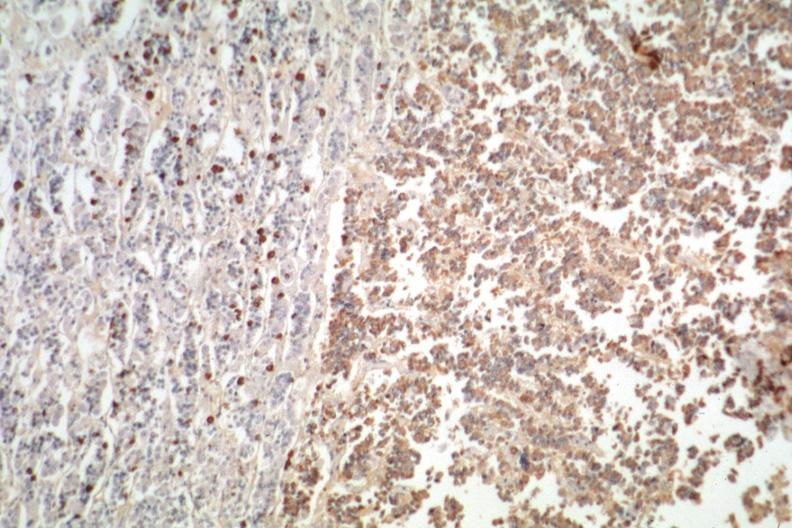what stain is positive?
Answer the question using a single word or phrase. Immunostain for growth hormone 